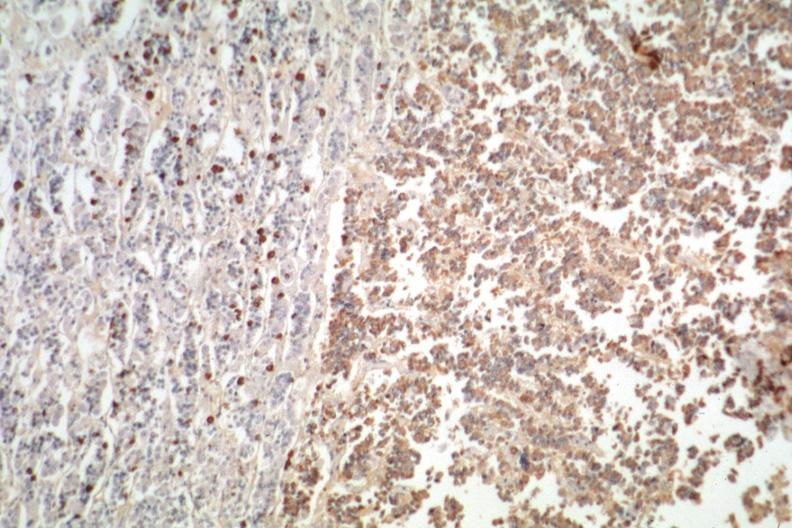what stain is positive?
Answer the question using a single word or phrase. Immunostain for growth hormone 